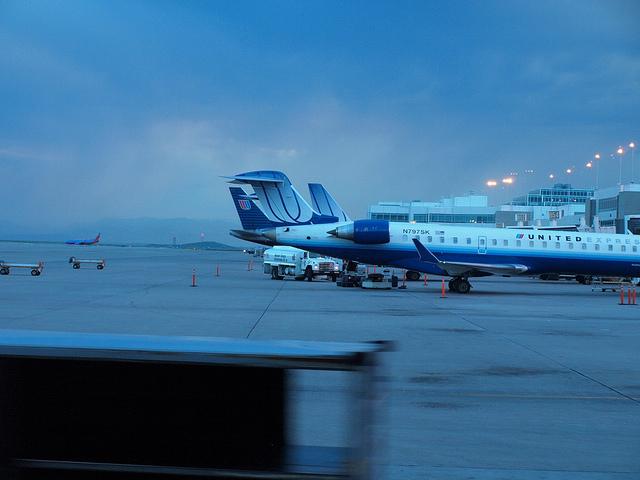Are the planes all the same?
Keep it brief. Yes. Is this jetliner flying low?
Concise answer only. No. What airline are the planes for?
Short answer required. United. Are there planes?
Keep it brief. Yes. Is it sunny?
Keep it brief. No. How many airplanes are pictured?
Answer briefly. 3. 